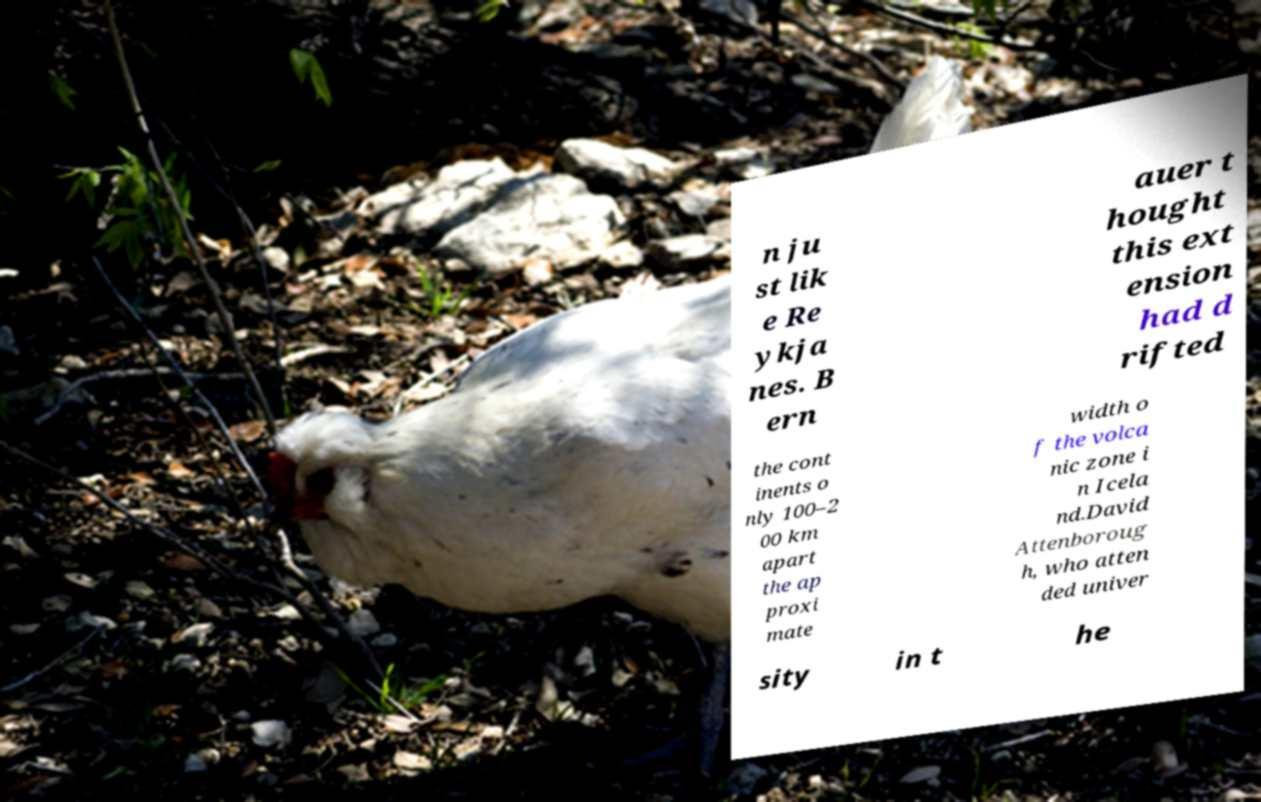Can you accurately transcribe the text from the provided image for me? n ju st lik e Re ykja nes. B ern auer t hought this ext ension had d rifted the cont inents o nly 100–2 00 km apart the ap proxi mate width o f the volca nic zone i n Icela nd.David Attenboroug h, who atten ded univer sity in t he 